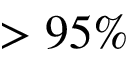Convert formula to latex. <formula><loc_0><loc_0><loc_500><loc_500>> 9 5 \%</formula> 